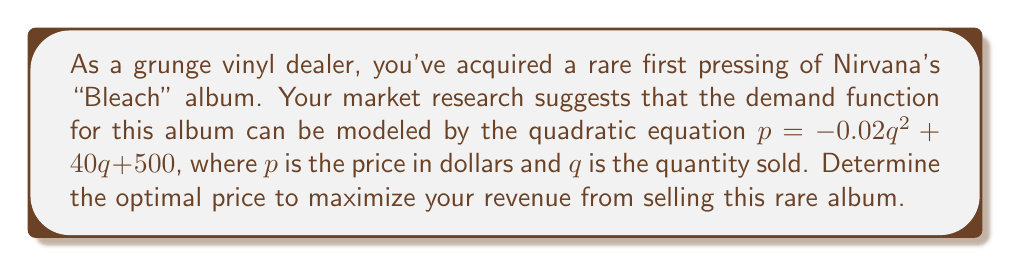Show me your answer to this math problem. To find the optimal price, we need to follow these steps:

1) First, we need to find the revenue function. Revenue is price times quantity:
   $R = pq = (-0.02q^2 + 40q + 500)q = -0.02q^3 + 40q^2 + 500q$

2) To maximize revenue, we need to find where the derivative of the revenue function equals zero:
   $\frac{dR}{dq} = -0.06q^2 + 80q + 500$

3) Set this equal to zero:
   $-0.06q^2 + 80q + 500 = 0$

4) This is a quadratic equation. We can solve it using the quadratic formula:
   $q = \frac{-b \pm \sqrt{b^2 - 4ac}}{2a}$

   Where $a = -0.06$, $b = 80$, and $c = 500$

5) Plugging in these values:
   $q = \frac{-80 \pm \sqrt{80^2 - 4(-0.06)(500)}}{2(-0.06)}$

6) Simplifying:
   $q = \frac{-80 \pm \sqrt{6400 + 120}}{-0.12} = \frac{-80 \pm \sqrt{6520}}{-0.12}$

7) This gives us two solutions:
   $q \approx 733.33$ or $q \approx 113.33$

8) The larger value corresponds to the maximum (the smaller to the minimum), so we use $q \approx 733.33$

9) To find the optimal price, we plug this back into our original demand function:
   $p = -0.02(733.33)^2 + 40(733.33) + 500 \approx 15,166.67$

Therefore, the optimal price is approximately $15,166.67.
Answer: $15,166.67 